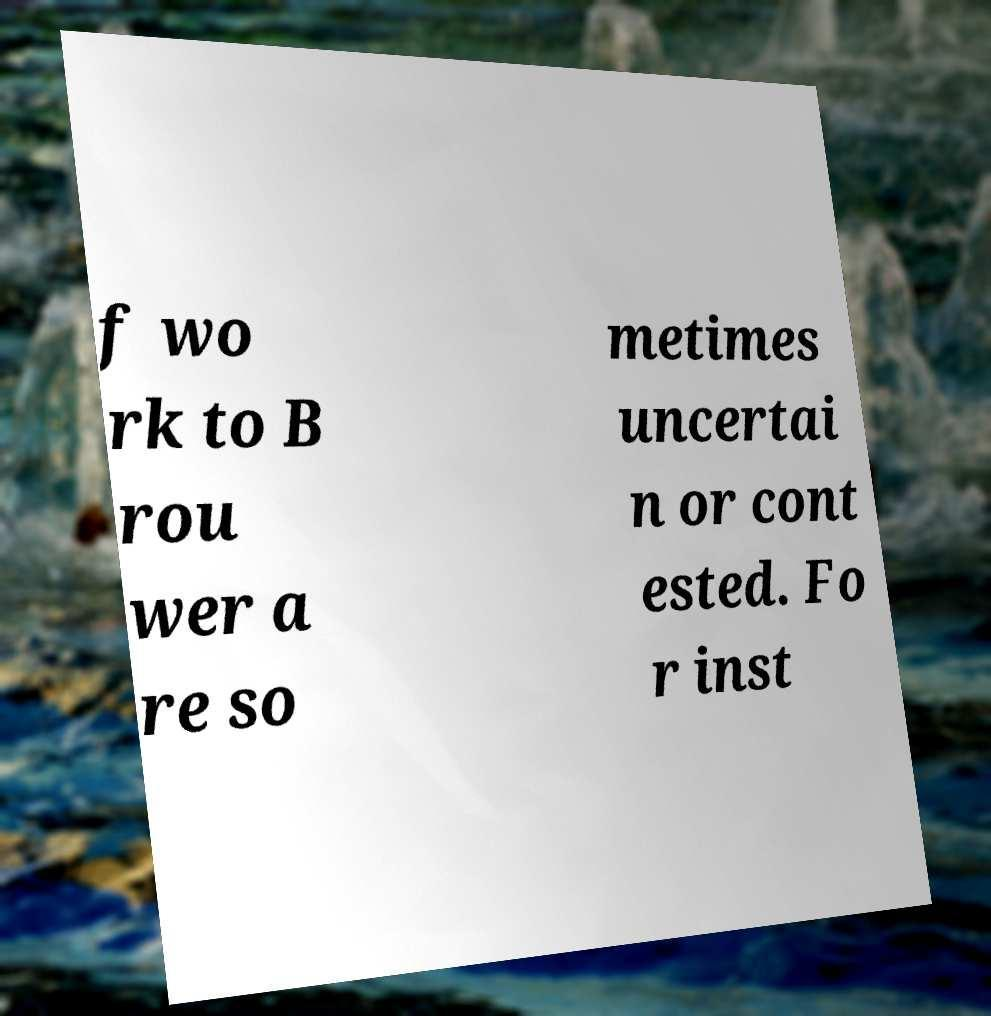Can you accurately transcribe the text from the provided image for me? f wo rk to B rou wer a re so metimes uncertai n or cont ested. Fo r inst 